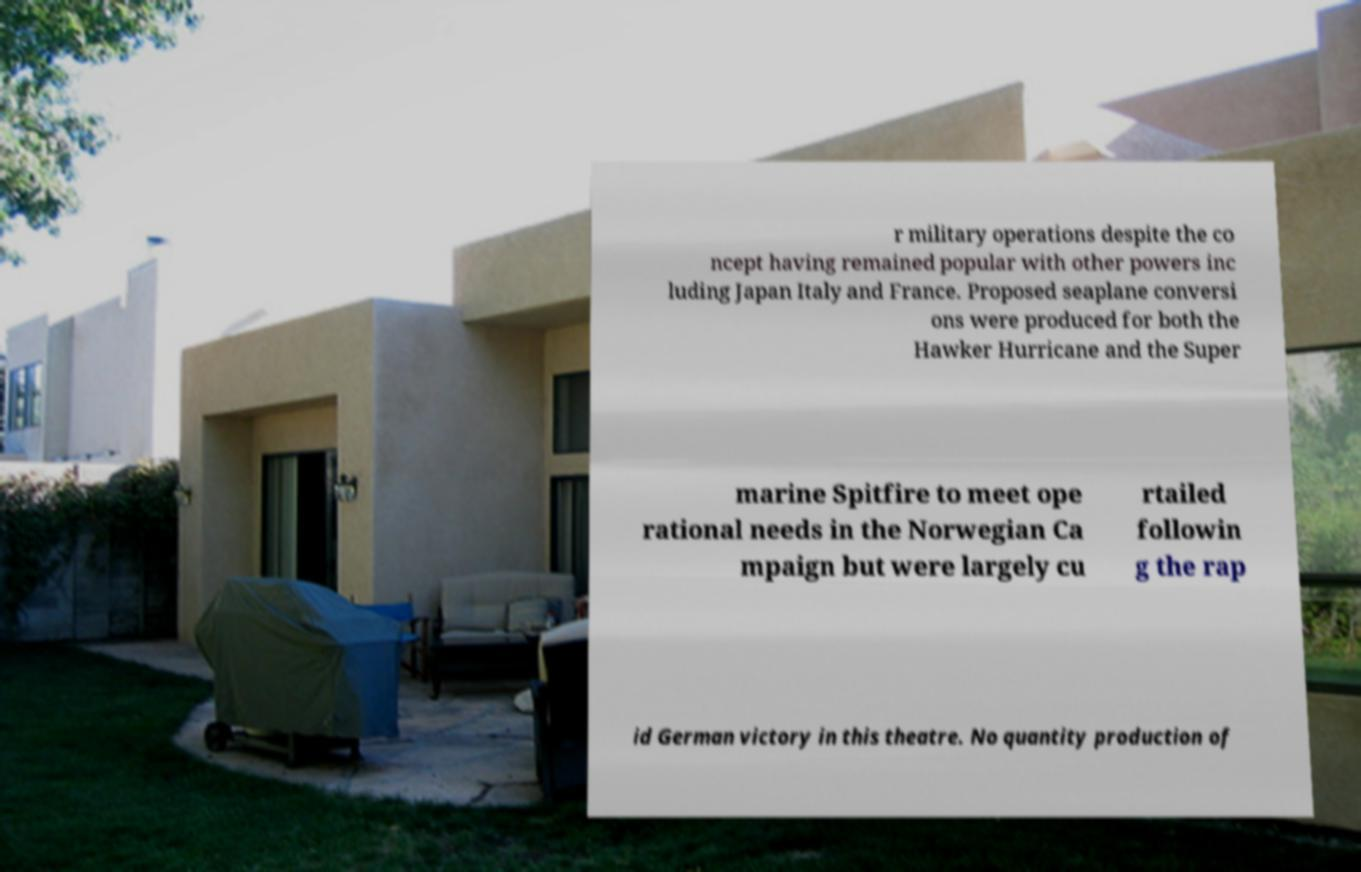Can you accurately transcribe the text from the provided image for me? r military operations despite the co ncept having remained popular with other powers inc luding Japan Italy and France. Proposed seaplane conversi ons were produced for both the Hawker Hurricane and the Super marine Spitfire to meet ope rational needs in the Norwegian Ca mpaign but were largely cu rtailed followin g the rap id German victory in this theatre. No quantity production of 